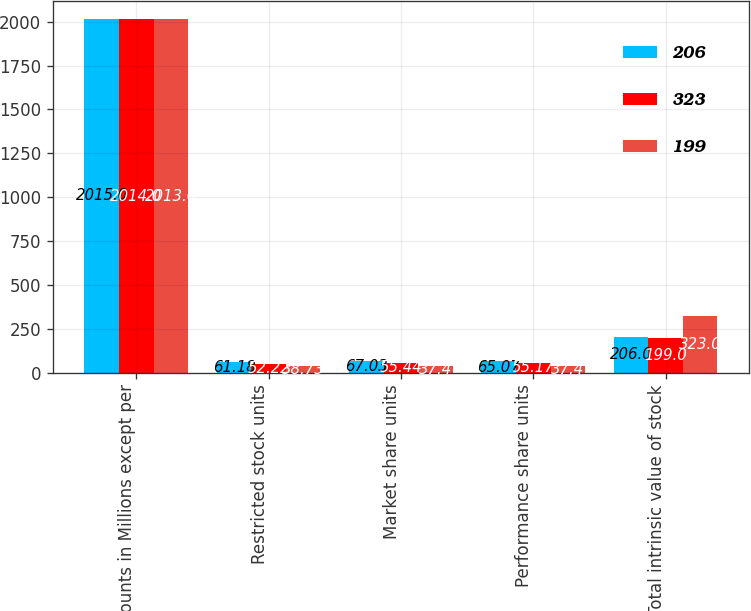<chart> <loc_0><loc_0><loc_500><loc_500><stacked_bar_chart><ecel><fcel>Amounts in Millions except per<fcel>Restricted stock units<fcel>Market share units<fcel>Performance share units<fcel>Total intrinsic value of stock<nl><fcel>206<fcel>2015<fcel>61.18<fcel>67.03<fcel>65.07<fcel>206<nl><fcel>323<fcel>2014<fcel>52.22<fcel>55.44<fcel>55.17<fcel>199<nl><fcel>199<fcel>2013<fcel>38.73<fcel>37.4<fcel>37.4<fcel>323<nl></chart> 